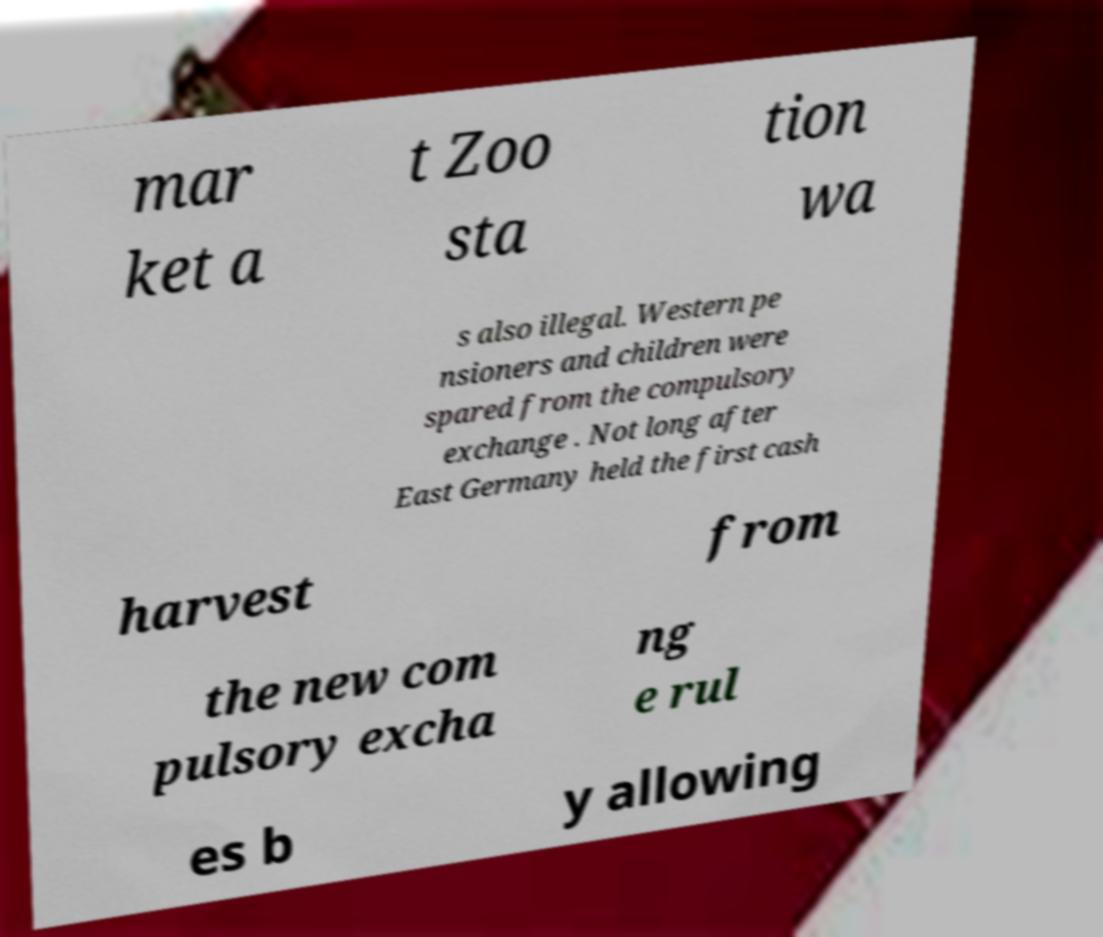For documentation purposes, I need the text within this image transcribed. Could you provide that? mar ket a t Zoo sta tion wa s also illegal. Western pe nsioners and children were spared from the compulsory exchange . Not long after East Germany held the first cash harvest from the new com pulsory excha ng e rul es b y allowing 